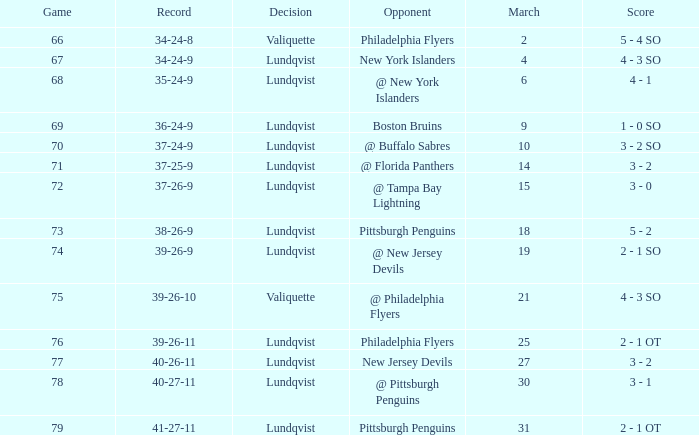Which opponent's march was 31? Pittsburgh Penguins. 